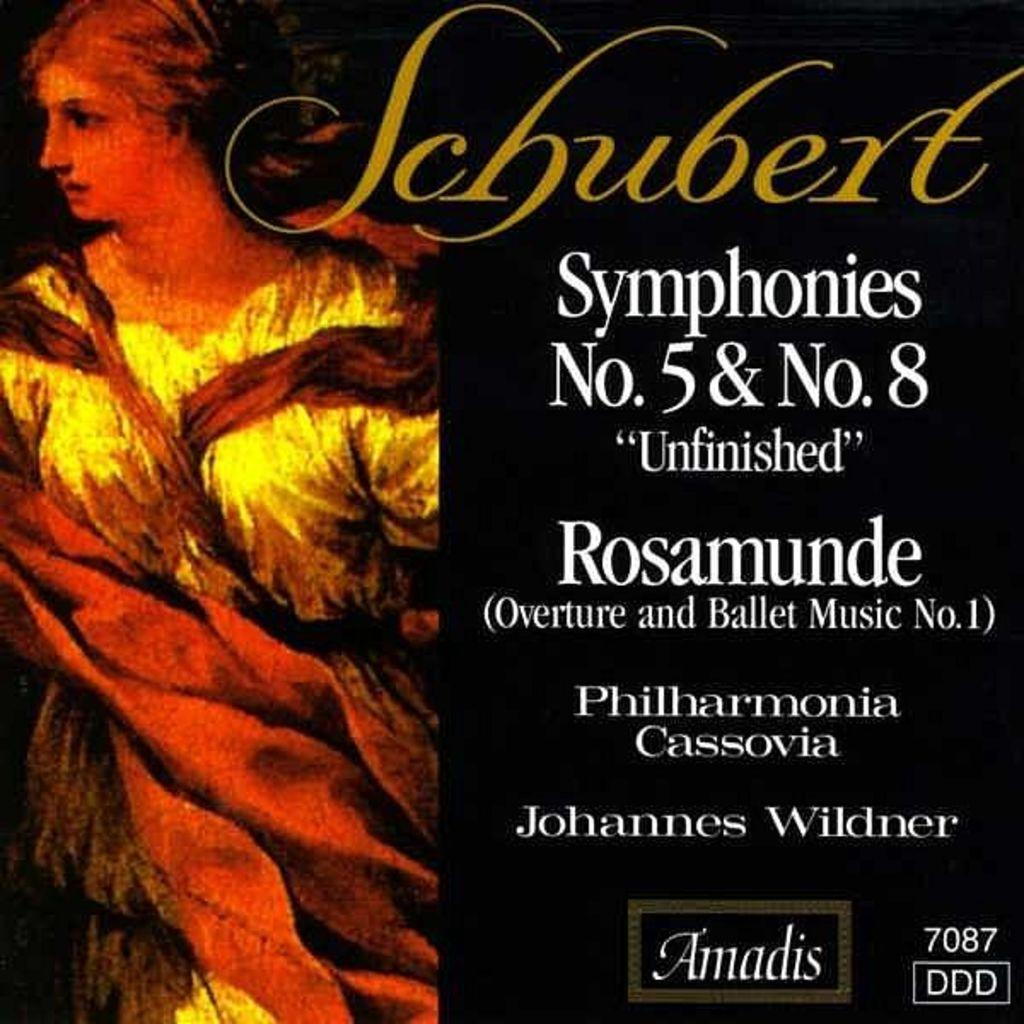<image>
Share a concise interpretation of the image provided. Johannes Wildner presents music of Schubert on this album. 